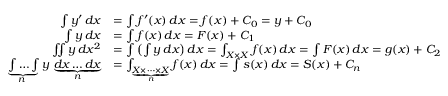<formula> <loc_0><loc_0><loc_500><loc_500>{ \begin{array} { r l } { \int y ^ { \prime } \, d x } & { = \int f ^ { \prime } ( x ) \, d x = f ( x ) + C _ { 0 } = y + C _ { 0 } } \\ { \int y \, d x } & { = \int f ( x ) \, d x = F ( x ) + C _ { 1 } } \\ { \iint y \, d x ^ { 2 } } & { = \int \left ( \int y \, d x \right ) d x = \int _ { X \times X } f ( x ) \, d x = \int F ( x ) \, d x = g ( x ) + C _ { 2 } } \\ { \underbrace { \int \dots \int } _ { \, n } y \, \underbrace { d x \dots d x } _ { n } } & { = \int _ { \underbrace { X \times \cdots \times X } _ { n } } f ( x ) \, d x = \int s ( x ) \, d x = S ( x ) + C _ { n } } \end{array} }</formula> 